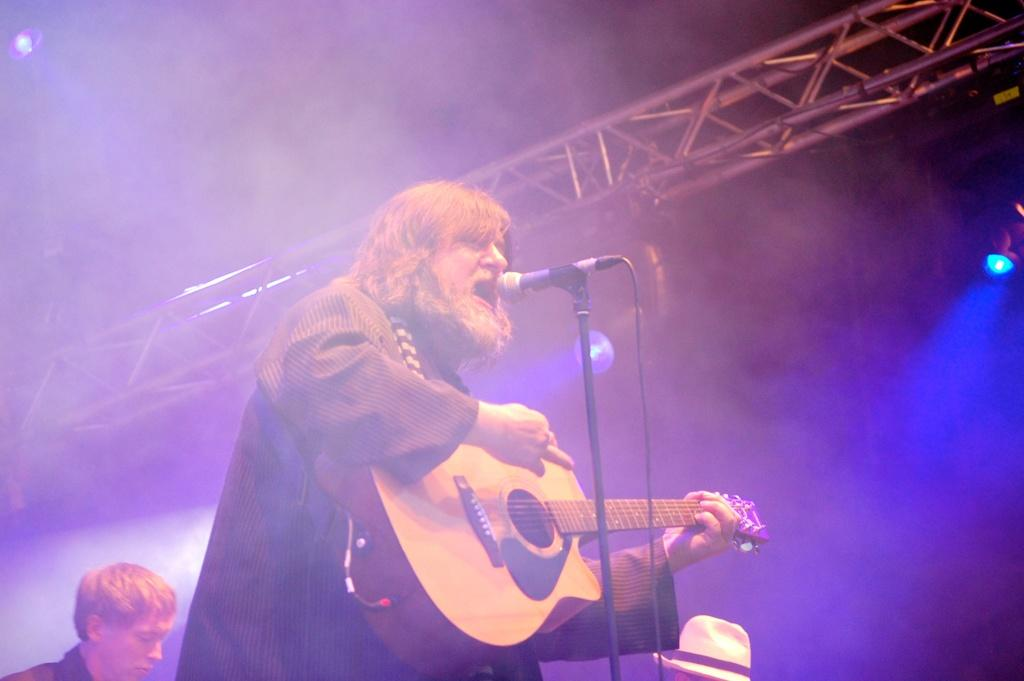What is the person in the image doing? The person is playing guitar and singing in the image. How is the person's voice being amplified? The person is using a microphone. Can you describe the person behind the guitar player? There is another person behind the guitar player, but their actions or appearance are not specified in the facts. What color is the hat on the right side of the image? The hat on the right side of the image is white. What type of crayon is the tramp using to draw on the texture of the wall in the image? There is no tramp, crayon, or texture on the wall present in the image. 